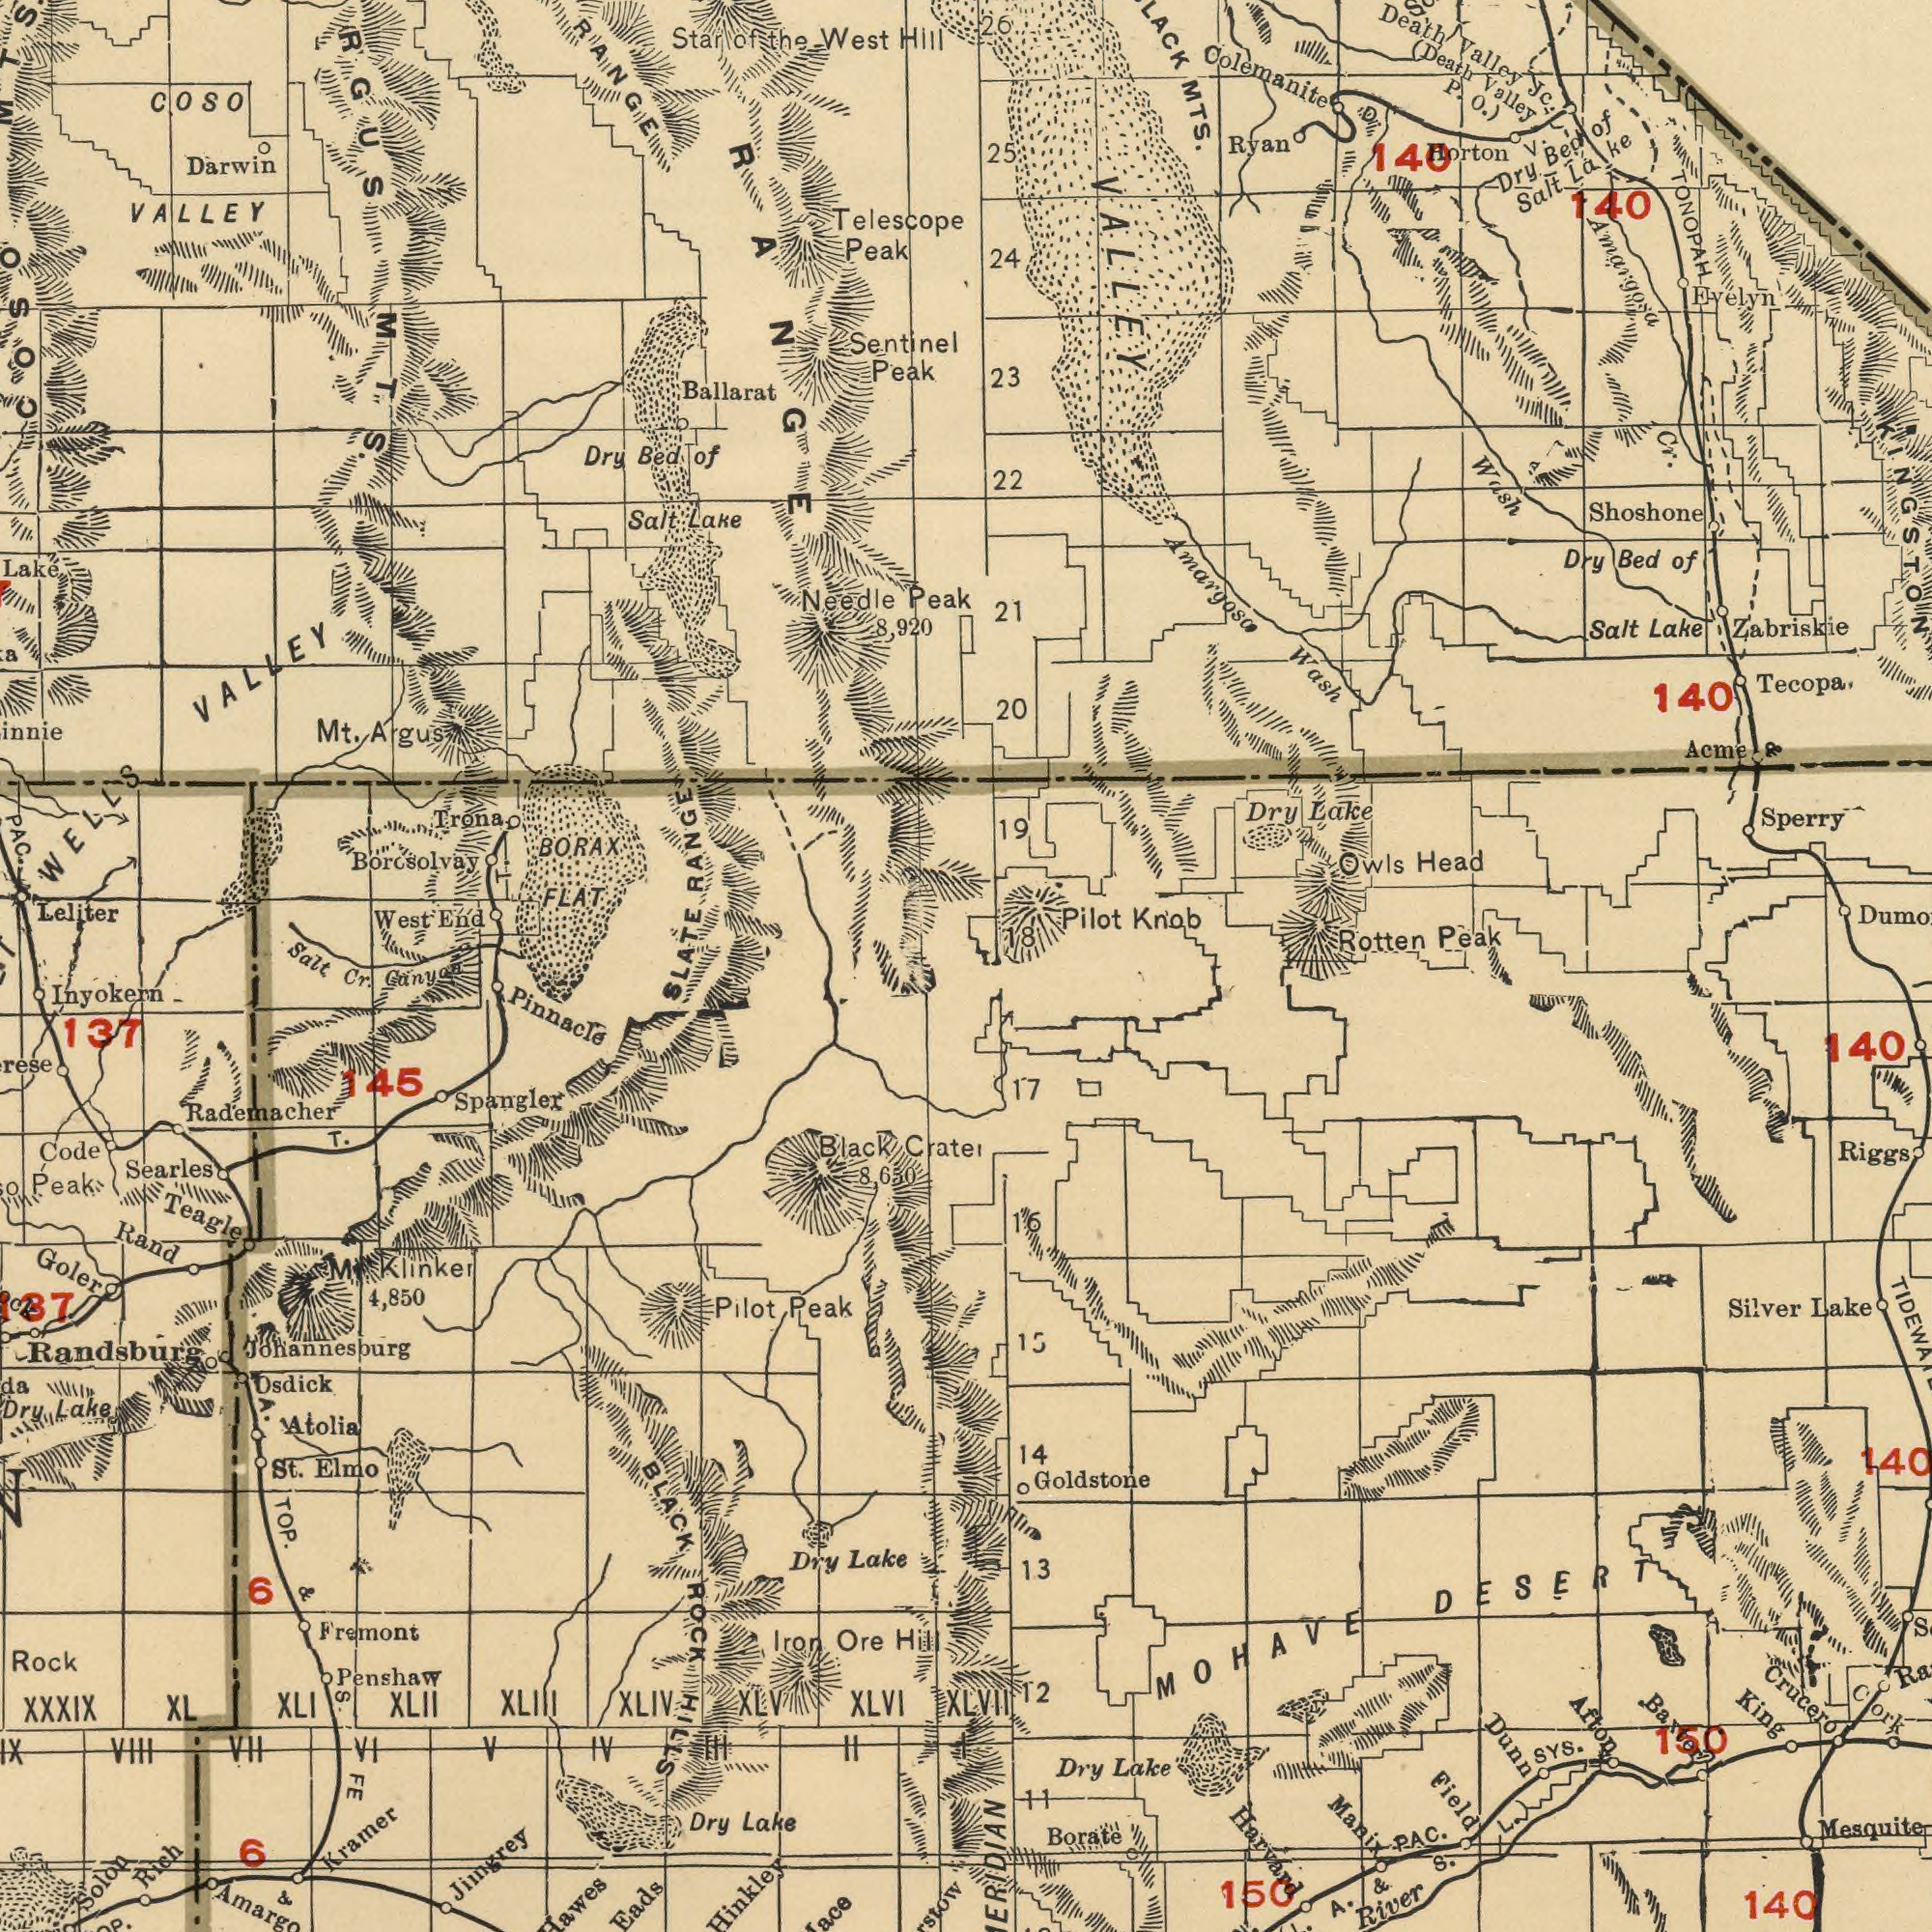What text can you see in the bottom-left section? Pinnacle Inyokern Randsburg Spangler Fremont XXXIX Kramer Goler Lake Rand BLACK Rock Elmo Osdick Penshaw Code Lake Teagle Dry Dry XLVI Ore Hinkley Lake Searles St. TOP. Solon Dry Atolia T. ROCK Rich Pilot XLIV Iron XLII Peak Jimgrey XLIII Cratel Klinker 137 Cr. Hill XL VIII FE XLI XLV IX Eads Johannesburg Peak Canyon Rademacher 145 VII 6 IV M II V 8,650 6 VI 4,850 Black I III & S. & HILLS A. What text appears in the top-right area of the image? Valley Rotten Peak Sperry Tecopa Evelyn Ryan Lake Death Dry MTS. Bed Head Wash 25 23 Salt Wash TONOPAH 20 Salt 26 Lake Owls 22 Jc. Amargosa Bed (Death 21 140 Horton Dry 18 24 Lake Knob Acme Valley 19 Zabriskie Pilot KINGSTON Cr. Amargosa P. 140 Dry of Shoshone O.) Colemanite VALLEY V. D. 140 of What text can you see in the top-left section? VALLEY FLAT Borosolvay BORAX Trona VALLEY Sentinel Needle Peak Salt Leliter Darwin Lake Ballarat PAC. Dry Lake SLATE West Bed Peak WELLS Peak Telescope Mt. Argus Salt ###RGUS RANGE West COSO End the 8,920 of MTS. Star Hill COSO of RANGE RANGE T. What text can you see in the bottom-right section? Harvard Crucero Goldstone Mesquite MOHAVE Lake Borate Lake River Riggs Field DESERT Silver King Dunn SYS. Dry 140 Manix 13 140 140 Cork 14 S. 17 150 15 12 L. 11 16 A. & Baxter Afton PAC. XLVII 160 